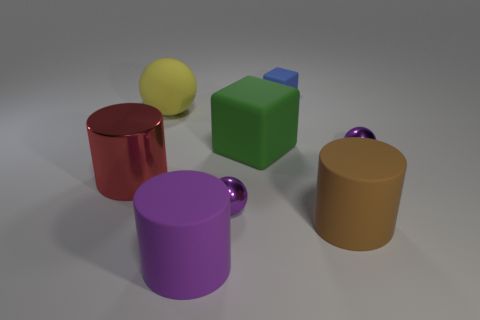Add 1 large red objects. How many objects exist? 9 Subtract all spheres. How many objects are left? 5 Add 3 purple matte cylinders. How many purple matte cylinders are left? 4 Add 2 small shiny objects. How many small shiny objects exist? 4 Subtract 0 brown cubes. How many objects are left? 8 Subtract all big blue shiny balls. Subtract all big red shiny things. How many objects are left? 7 